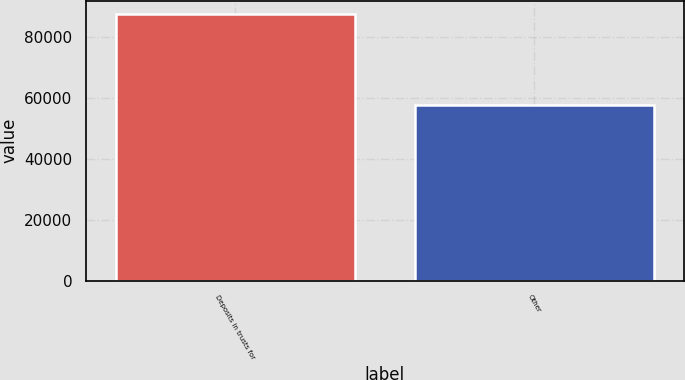<chart> <loc_0><loc_0><loc_500><loc_500><bar_chart><fcel>Deposits in trusts for<fcel>Other<nl><fcel>87646<fcel>57791<nl></chart> 